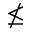<formula> <loc_0><loc_0><loc_500><loc_500>\nleq</formula> 